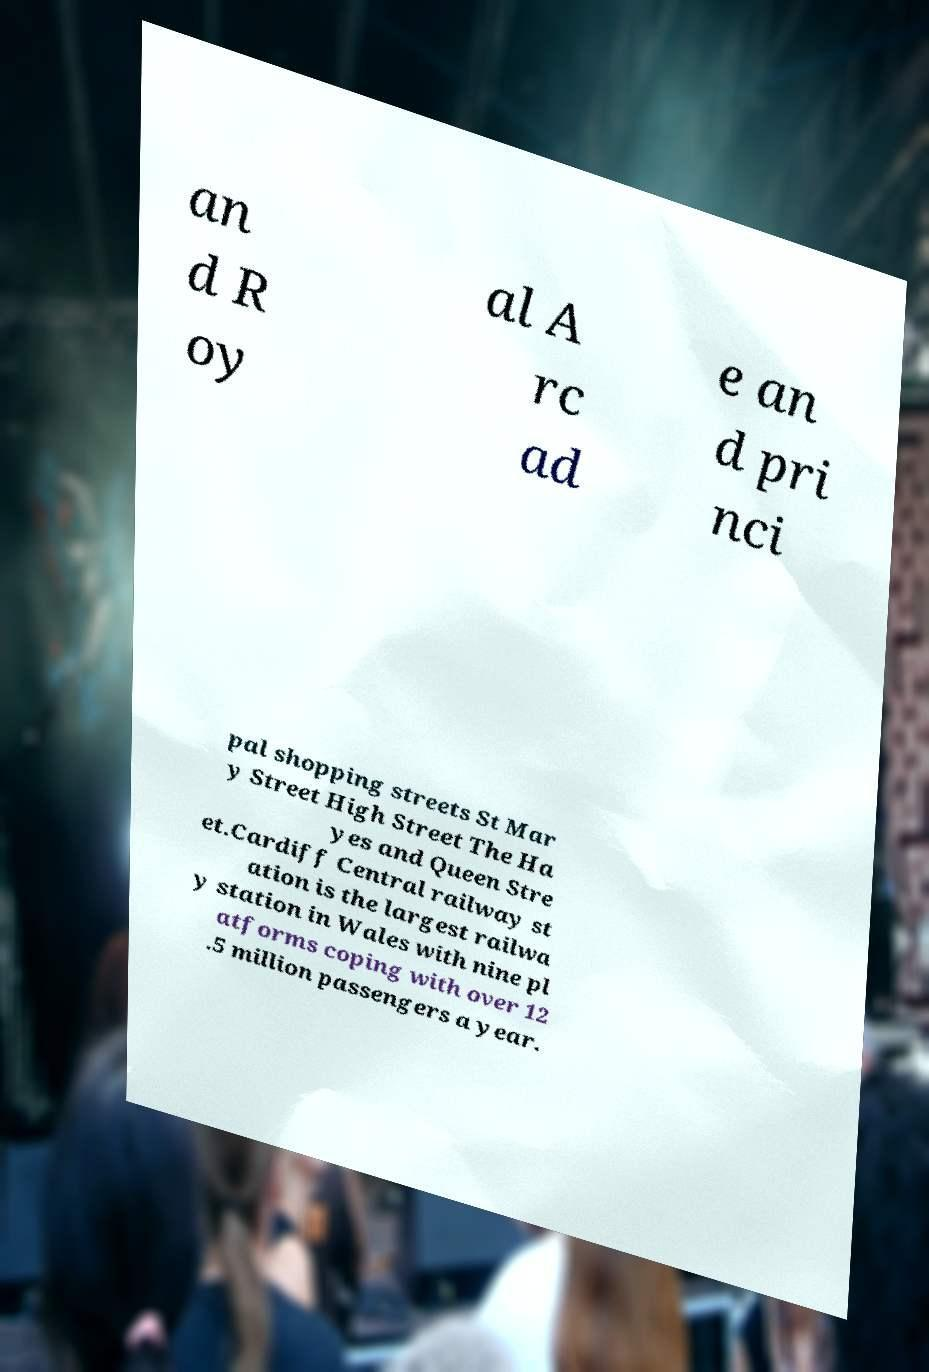Please identify and transcribe the text found in this image. an d R oy al A rc ad e an d pri nci pal shopping streets St Mar y Street High Street The Ha yes and Queen Stre et.Cardiff Central railway st ation is the largest railwa y station in Wales with nine pl atforms coping with over 12 .5 million passengers a year. 